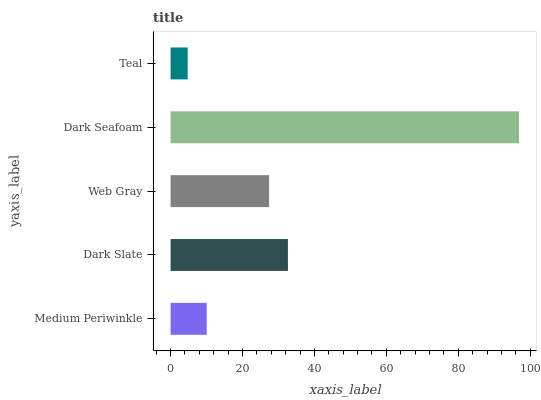Is Teal the minimum?
Answer yes or no. Yes. Is Dark Seafoam the maximum?
Answer yes or no. Yes. Is Dark Slate the minimum?
Answer yes or no. No. Is Dark Slate the maximum?
Answer yes or no. No. Is Dark Slate greater than Medium Periwinkle?
Answer yes or no. Yes. Is Medium Periwinkle less than Dark Slate?
Answer yes or no. Yes. Is Medium Periwinkle greater than Dark Slate?
Answer yes or no. No. Is Dark Slate less than Medium Periwinkle?
Answer yes or no. No. Is Web Gray the high median?
Answer yes or no. Yes. Is Web Gray the low median?
Answer yes or no. Yes. Is Teal the high median?
Answer yes or no. No. Is Medium Periwinkle the low median?
Answer yes or no. No. 